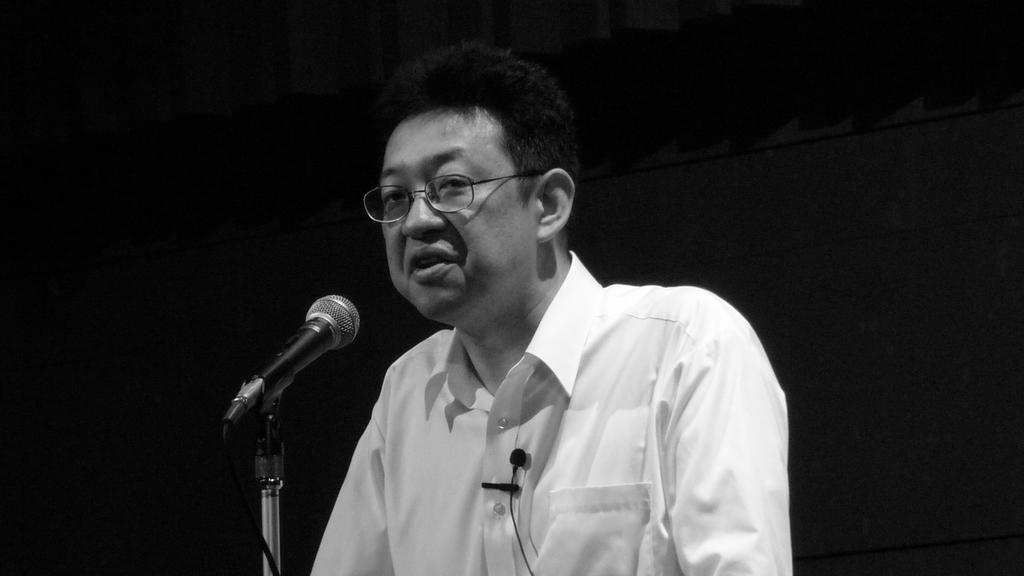Who is the main subject in the image? There is a man in the center of the image. What object is in front of the man? There is a microphone in front of the man. What can be seen in the background of the image? There is a curtain in the background of the image. What type of snail can be seen crawling on the microphone in the image? There is no snail present in the image; the microphone is not associated with any snail. 